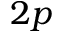<formula> <loc_0><loc_0><loc_500><loc_500>2 p</formula> 